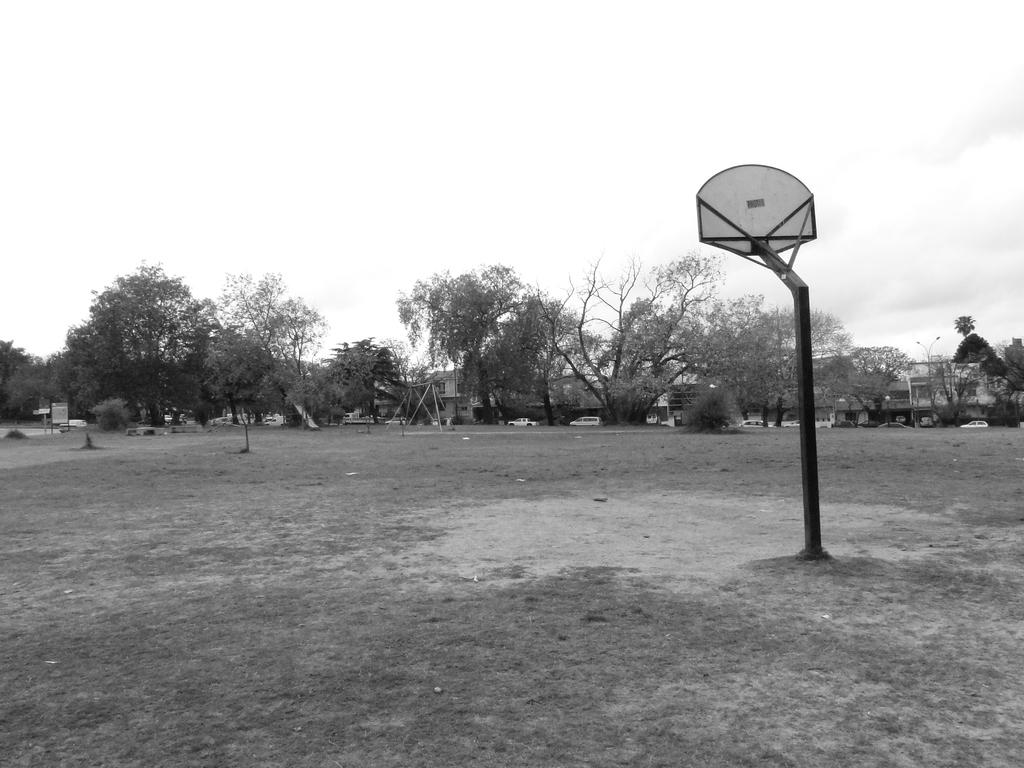What is the color scheme of the image? The image is black and white. What can be seen on the right side of the image? There is a pole on the right side of the image. What type of natural environment is visible in the background of the image? Trees, grass, and the sky are visible in the background of the image. What man-made structures can be seen in the background of the image? Cars and buildings are visible in the background of the image. How many plants are visible in the image? There are no plants visible in the image; the image is black and white, and the focus is on a pole and the background elements. 